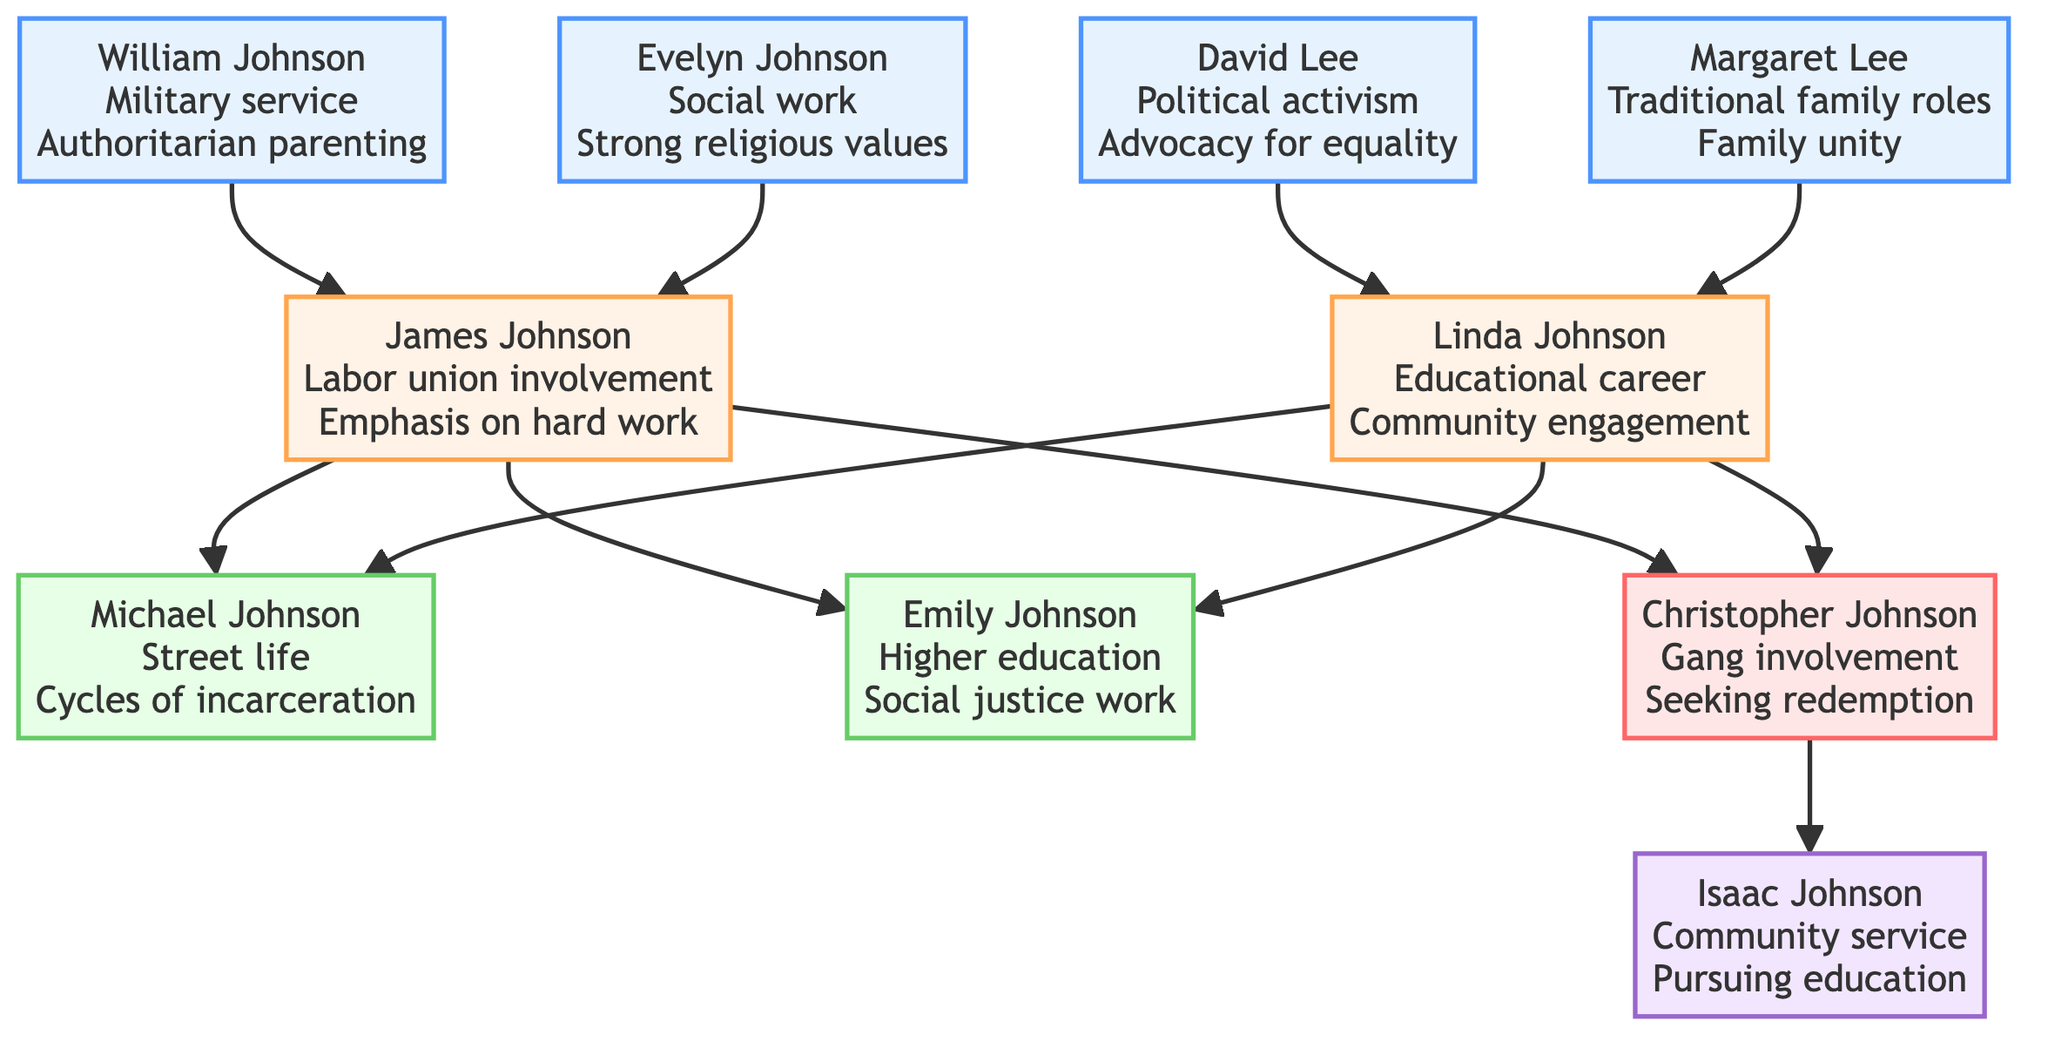What is the influence of Christopher Johnson? Christopher Johnson's influence is described as "Former gang member, converting to Islam for redemption." This information is directly found in the section labeled "Self" within the diagram.
Answer: Former gang member, converting to Islam for redemption How many grandparents are listed in the diagram? The diagram shows four grandparents: William Johnson, Evelyn Johnson, David Lee, and Margaret Lee. Counting them gives a total of four.
Answer: 4 What life choice is associated with Emily Johnson? The life choice associated with Emily Johnson is "Higher education." This can be found in the "Younger_Sister" section of the diagram.
Answer: Higher education Who is the father of Christopher Johnson? The father of Christopher Johnson is James Johnson. This relationship is established in the parent section labeled under "Parents."
Answer: James Johnson What type of life choices did David Lee promote? David Lee promoted "Political activism" and "Advocacy for equality." These choices are listed under his influence in the grandparents' section.
Answer: Political activism, Advocacy for equality What is the influence of Michael Johnson? Michael Johnson's influence is described as "High school dropout, involved in gang activities." This information is stated in the sibling section of the diagram.
Answer: High school dropout, involved in gang activities What key value did Evelyn Johnson emphasize? Evelyn Johnson emphasized "Strong religious values." This is reflected in her influence within the grandparents' section.
Answer: Strong religious values Which sibling pursued social justice work? The sibling who pursued social justice work is Emily Johnson. This is evident from her life choices mentioned in the sibling section.
Answer: Emily Johnson Which grandparent was a military veteran? The grandparent who was a military veteran is William Johnson. His influence is clearly stated in the grandparents' section of the diagram.
Answer: William Johnson 